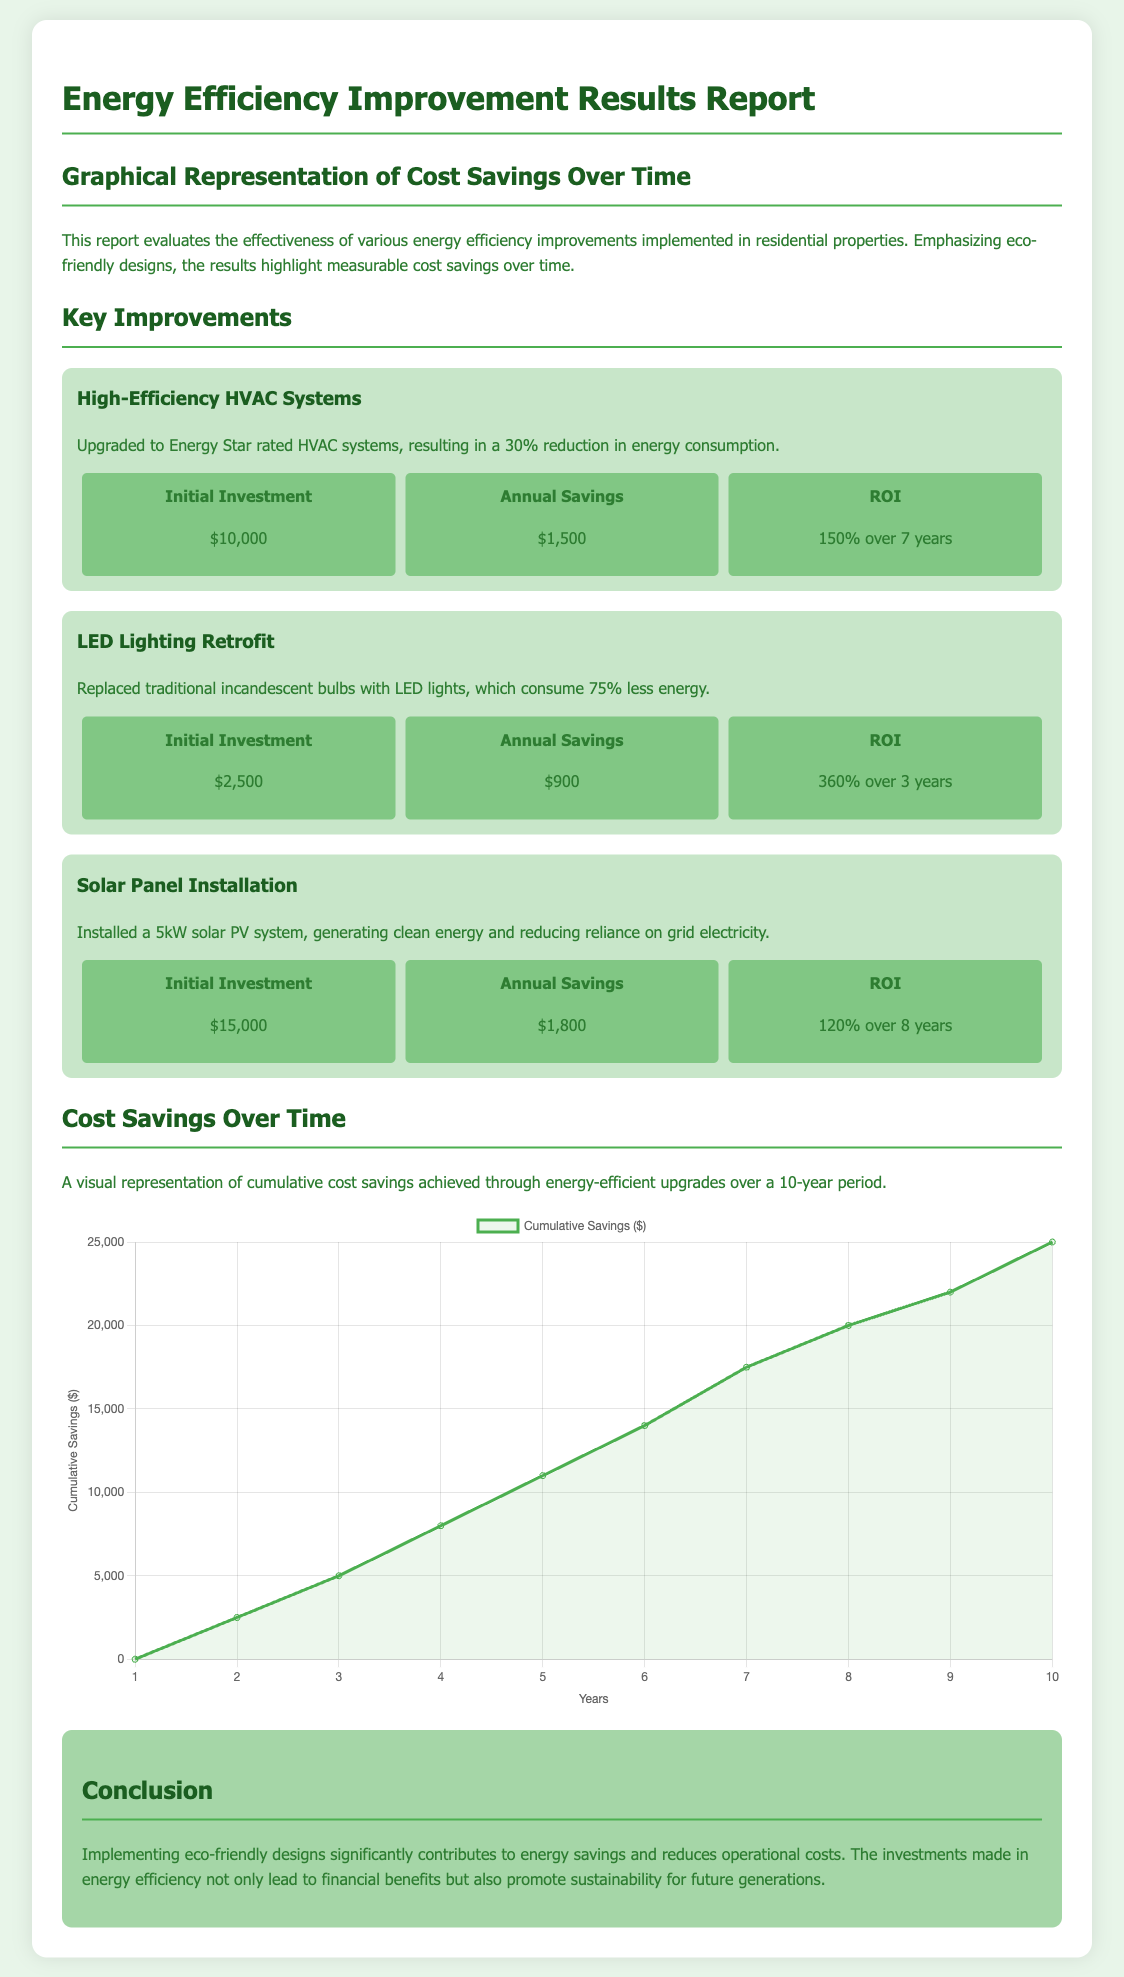What is the initial investment for High-Efficiency HVAC Systems? The initial investment for High-Efficiency HVAC Systems is listed in the report.
Answer: $10,000 What is the annual savings from the LED Lighting Retrofit? The annual savings from replacing incandescent bulbs with LED lights is detailed in the cost-savings section.
Answer: $900 What is the ROI for Solar Panel Installation? The return on investment for the solar PV system is stated in the document.
Answer: 120% over 8 years How much cumulative savings is projected after 10 years? The cumulative savings over a 10-year period is illustrated in the graphical representation.
Answer: $25,000 What percentage reduction in energy consumption do High-Efficiency HVAC Systems provide? The report mentions a specific percentage reduction in energy consumption for this improvement.
Answer: 30% Which improvement had the highest ROI? By comparing the ROI of all improvements, we can determine which had the highest return.
Answer: LED Lighting Retrofit What type of chart is used to represent cumulative savings? The graphical representation uses a specific type of chart, which is noted in the script section of the document.
Answer: Line chart What is the background color of the body in the document? The background color is defined in the style section, which represents the overall theme of the document.
Answer: #e8f5e9 What type of systems were replaced with LED lights? The document specifies the type of lighting that was replaced as part of the improvement.
Answer: Incandescent bulbs 